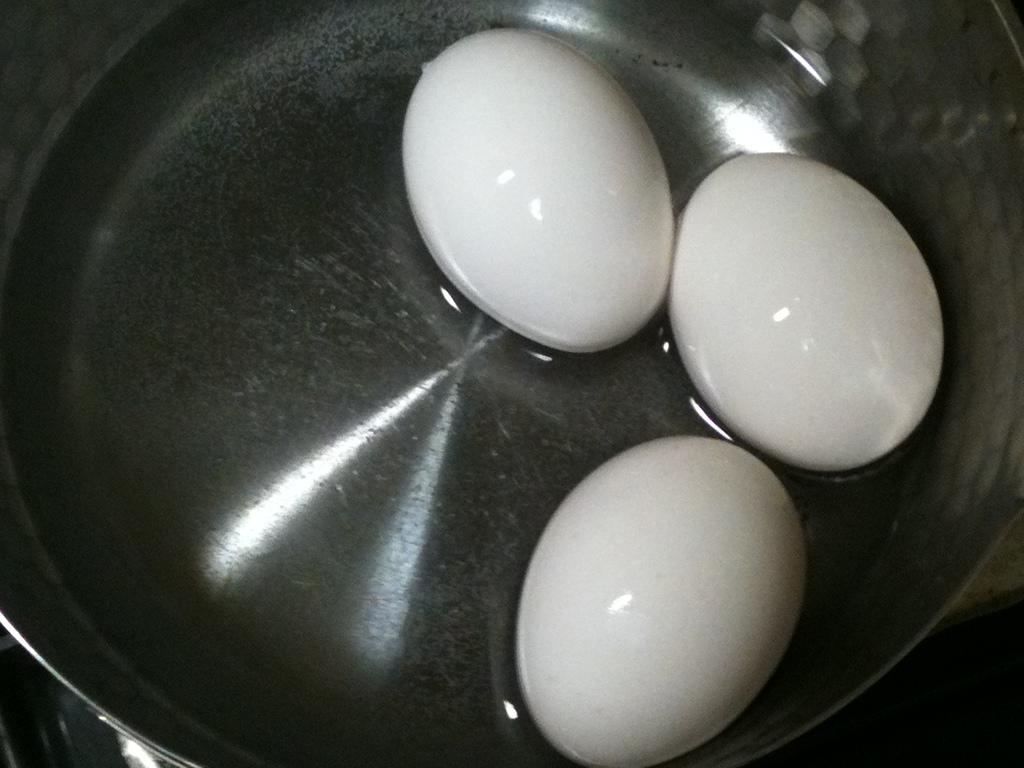What is in the bowl that is visible in the image? There is a bowl in the image, and it contains water. What else can be seen in the bowl besides water? There are three eggs in the bowl. What is the color of the eggs in the bowl? The eggs in the bowl are white in color. How many quarters are floating on the wax in the image? There is no wax or quarters present in the image. The image only contains a bowl with water and three white eggs. 